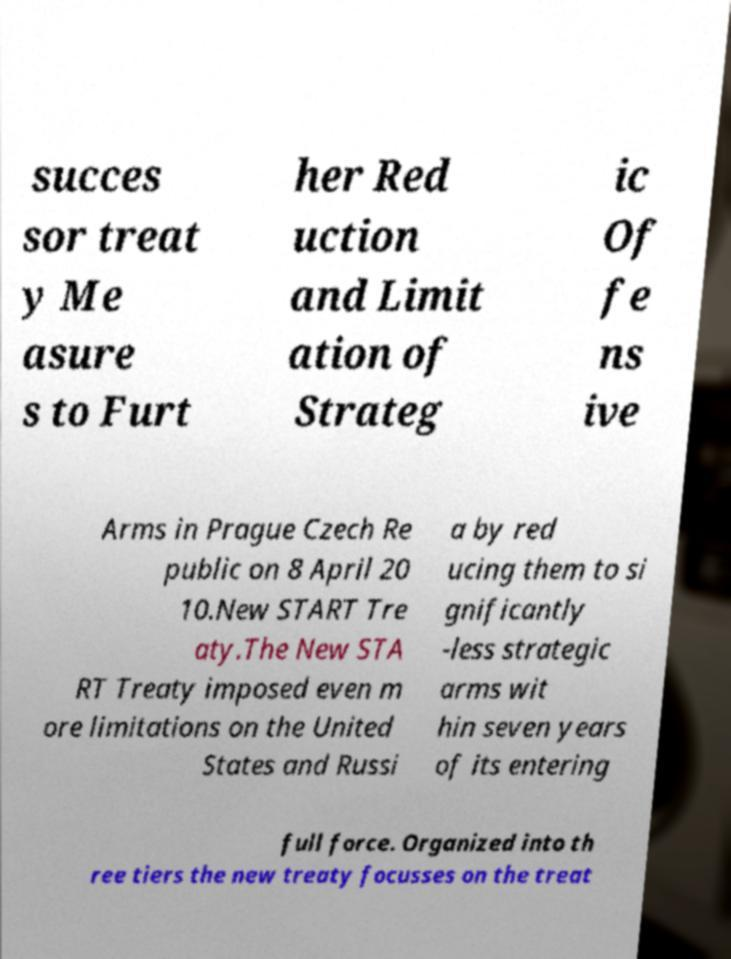Could you extract and type out the text from this image? succes sor treat y Me asure s to Furt her Red uction and Limit ation of Strateg ic Of fe ns ive Arms in Prague Czech Re public on 8 April 20 10.New START Tre aty.The New STA RT Treaty imposed even m ore limitations on the United States and Russi a by red ucing them to si gnificantly -less strategic arms wit hin seven years of its entering full force. Organized into th ree tiers the new treaty focusses on the treat 